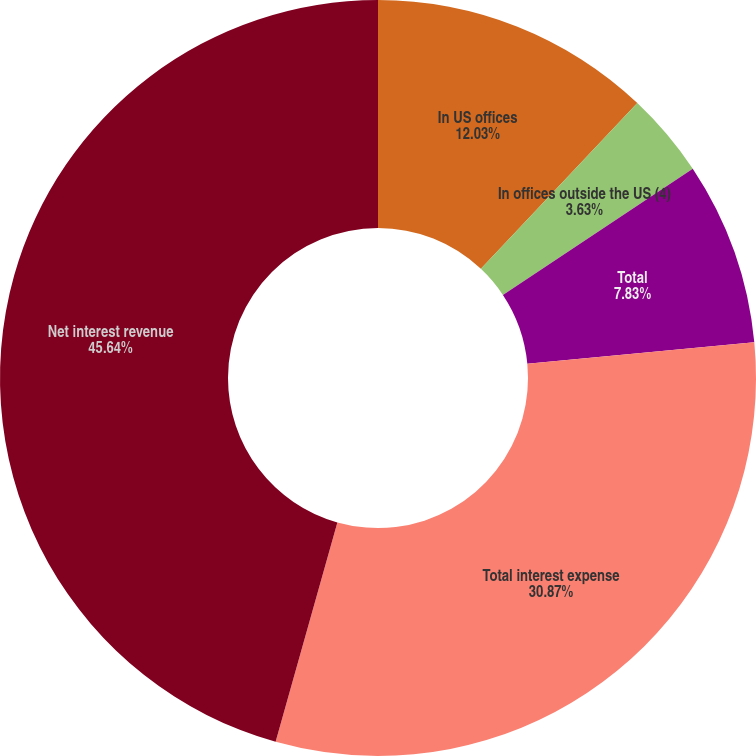Convert chart to OTSL. <chart><loc_0><loc_0><loc_500><loc_500><pie_chart><fcel>In US offices<fcel>In offices outside the US (4)<fcel>Total<fcel>Total interest expense<fcel>Net interest revenue<nl><fcel>12.03%<fcel>3.63%<fcel>7.83%<fcel>30.87%<fcel>45.63%<nl></chart> 